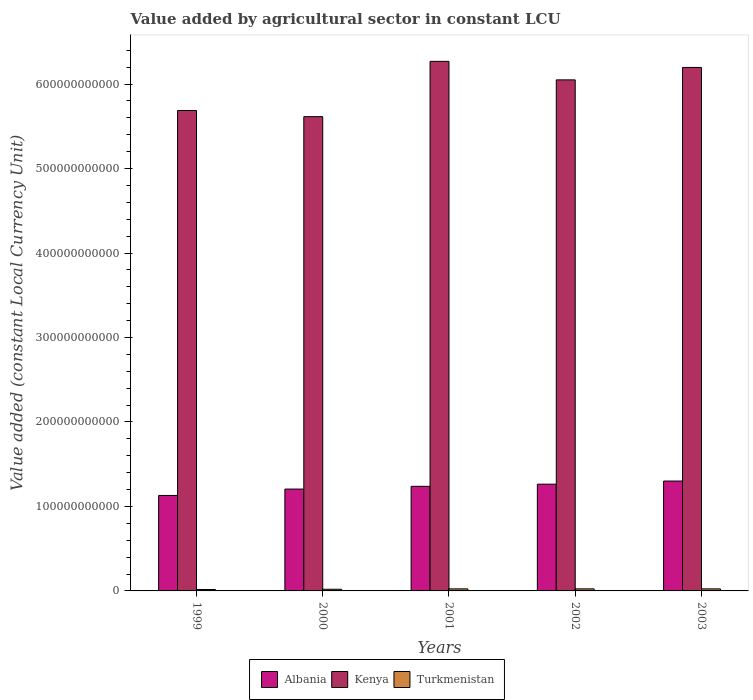How many different coloured bars are there?
Make the answer very short. 3. Are the number of bars per tick equal to the number of legend labels?
Provide a short and direct response. Yes. What is the label of the 1st group of bars from the left?
Provide a succinct answer. 1999. In how many cases, is the number of bars for a given year not equal to the number of legend labels?
Provide a succinct answer. 0. What is the value added by agricultural sector in Turkmenistan in 2001?
Give a very brief answer. 2.43e+09. Across all years, what is the maximum value added by agricultural sector in Turkmenistan?
Provide a short and direct response. 2.43e+09. Across all years, what is the minimum value added by agricultural sector in Albania?
Your response must be concise. 1.13e+11. In which year was the value added by agricultural sector in Albania minimum?
Give a very brief answer. 1999. What is the total value added by agricultural sector in Albania in the graph?
Your answer should be compact. 6.14e+11. What is the difference between the value added by agricultural sector in Turkmenistan in 2001 and that in 2002?
Provide a succinct answer. -2.31e+06. What is the difference between the value added by agricultural sector in Turkmenistan in 2003 and the value added by agricultural sector in Kenya in 2002?
Provide a succinct answer. -6.03e+11. What is the average value added by agricultural sector in Albania per year?
Your response must be concise. 1.23e+11. In the year 2001, what is the difference between the value added by agricultural sector in Turkmenistan and value added by agricultural sector in Albania?
Make the answer very short. -1.21e+11. What is the ratio of the value added by agricultural sector in Turkmenistan in 2000 to that in 2001?
Your answer should be very brief. 0.81. What is the difference between the highest and the second highest value added by agricultural sector in Turkmenistan?
Your response must be concise. 2.41e+06. What is the difference between the highest and the lowest value added by agricultural sector in Kenya?
Your response must be concise. 6.55e+1. What does the 1st bar from the left in 2003 represents?
Give a very brief answer. Albania. What does the 3rd bar from the right in 2001 represents?
Provide a succinct answer. Albania. How many bars are there?
Your answer should be compact. 15. What is the difference between two consecutive major ticks on the Y-axis?
Offer a terse response. 1.00e+11. Where does the legend appear in the graph?
Keep it short and to the point. Bottom center. How are the legend labels stacked?
Your response must be concise. Horizontal. What is the title of the graph?
Your response must be concise. Value added by agricultural sector in constant LCU. Does "Fiji" appear as one of the legend labels in the graph?
Offer a terse response. No. What is the label or title of the Y-axis?
Make the answer very short. Value added (constant Local Currency Unit). What is the Value added (constant Local Currency Unit) of Albania in 1999?
Your answer should be very brief. 1.13e+11. What is the Value added (constant Local Currency Unit) in Kenya in 1999?
Give a very brief answer. 5.69e+11. What is the Value added (constant Local Currency Unit) of Turkmenistan in 1999?
Your response must be concise. 1.69e+09. What is the Value added (constant Local Currency Unit) of Albania in 2000?
Your answer should be very brief. 1.21e+11. What is the Value added (constant Local Currency Unit) in Kenya in 2000?
Provide a succinct answer. 5.61e+11. What is the Value added (constant Local Currency Unit) of Turkmenistan in 2000?
Keep it short and to the point. 1.98e+09. What is the Value added (constant Local Currency Unit) in Albania in 2001?
Your answer should be very brief. 1.24e+11. What is the Value added (constant Local Currency Unit) of Kenya in 2001?
Give a very brief answer. 6.27e+11. What is the Value added (constant Local Currency Unit) in Turkmenistan in 2001?
Make the answer very short. 2.43e+09. What is the Value added (constant Local Currency Unit) in Albania in 2002?
Ensure brevity in your answer.  1.26e+11. What is the Value added (constant Local Currency Unit) in Kenya in 2002?
Give a very brief answer. 6.05e+11. What is the Value added (constant Local Currency Unit) of Turkmenistan in 2002?
Provide a succinct answer. 2.43e+09. What is the Value added (constant Local Currency Unit) in Albania in 2003?
Your answer should be compact. 1.30e+11. What is the Value added (constant Local Currency Unit) of Kenya in 2003?
Your response must be concise. 6.20e+11. What is the Value added (constant Local Currency Unit) in Turkmenistan in 2003?
Your answer should be compact. 2.43e+09. Across all years, what is the maximum Value added (constant Local Currency Unit) of Albania?
Your answer should be compact. 1.30e+11. Across all years, what is the maximum Value added (constant Local Currency Unit) of Kenya?
Offer a terse response. 6.27e+11. Across all years, what is the maximum Value added (constant Local Currency Unit) of Turkmenistan?
Your answer should be very brief. 2.43e+09. Across all years, what is the minimum Value added (constant Local Currency Unit) of Albania?
Provide a short and direct response. 1.13e+11. Across all years, what is the minimum Value added (constant Local Currency Unit) in Kenya?
Provide a succinct answer. 5.61e+11. Across all years, what is the minimum Value added (constant Local Currency Unit) in Turkmenistan?
Provide a short and direct response. 1.69e+09. What is the total Value added (constant Local Currency Unit) of Albania in the graph?
Your answer should be very brief. 6.14e+11. What is the total Value added (constant Local Currency Unit) of Kenya in the graph?
Offer a very short reply. 2.98e+12. What is the total Value added (constant Local Currency Unit) of Turkmenistan in the graph?
Offer a very short reply. 1.10e+1. What is the difference between the Value added (constant Local Currency Unit) of Albania in 1999 and that in 2000?
Offer a very short reply. -7.56e+09. What is the difference between the Value added (constant Local Currency Unit) in Kenya in 1999 and that in 2000?
Make the answer very short. 7.26e+09. What is the difference between the Value added (constant Local Currency Unit) of Turkmenistan in 1999 and that in 2000?
Offer a very short reply. -2.87e+08. What is the difference between the Value added (constant Local Currency Unit) of Albania in 1999 and that in 2001?
Offer a terse response. -1.08e+1. What is the difference between the Value added (constant Local Currency Unit) in Kenya in 1999 and that in 2001?
Ensure brevity in your answer.  -5.82e+1. What is the difference between the Value added (constant Local Currency Unit) of Turkmenistan in 1999 and that in 2001?
Your answer should be compact. -7.41e+08. What is the difference between the Value added (constant Local Currency Unit) in Albania in 1999 and that in 2002?
Keep it short and to the point. -1.33e+1. What is the difference between the Value added (constant Local Currency Unit) in Kenya in 1999 and that in 2002?
Your response must be concise. -3.63e+1. What is the difference between the Value added (constant Local Currency Unit) in Turkmenistan in 1999 and that in 2002?
Provide a short and direct response. -7.44e+08. What is the difference between the Value added (constant Local Currency Unit) in Albania in 1999 and that in 2003?
Keep it short and to the point. -1.71e+1. What is the difference between the Value added (constant Local Currency Unit) in Kenya in 1999 and that in 2003?
Provide a succinct answer. -5.10e+1. What is the difference between the Value added (constant Local Currency Unit) in Turkmenistan in 1999 and that in 2003?
Give a very brief answer. -7.46e+08. What is the difference between the Value added (constant Local Currency Unit) of Albania in 2000 and that in 2001?
Keep it short and to the point. -3.25e+09. What is the difference between the Value added (constant Local Currency Unit) in Kenya in 2000 and that in 2001?
Offer a terse response. -6.55e+1. What is the difference between the Value added (constant Local Currency Unit) in Turkmenistan in 2000 and that in 2001?
Offer a terse response. -4.54e+08. What is the difference between the Value added (constant Local Currency Unit) of Albania in 2000 and that in 2002?
Ensure brevity in your answer.  -5.79e+09. What is the difference between the Value added (constant Local Currency Unit) in Kenya in 2000 and that in 2002?
Your answer should be very brief. -4.35e+1. What is the difference between the Value added (constant Local Currency Unit) of Turkmenistan in 2000 and that in 2002?
Provide a succinct answer. -4.57e+08. What is the difference between the Value added (constant Local Currency Unit) in Albania in 2000 and that in 2003?
Your answer should be compact. -9.51e+09. What is the difference between the Value added (constant Local Currency Unit) in Kenya in 2000 and that in 2003?
Provide a short and direct response. -5.82e+1. What is the difference between the Value added (constant Local Currency Unit) of Turkmenistan in 2000 and that in 2003?
Offer a very short reply. -4.59e+08. What is the difference between the Value added (constant Local Currency Unit) of Albania in 2001 and that in 2002?
Your answer should be compact. -2.54e+09. What is the difference between the Value added (constant Local Currency Unit) in Kenya in 2001 and that in 2002?
Provide a succinct answer. 2.19e+1. What is the difference between the Value added (constant Local Currency Unit) of Turkmenistan in 2001 and that in 2002?
Provide a short and direct response. -2.31e+06. What is the difference between the Value added (constant Local Currency Unit) in Albania in 2001 and that in 2003?
Ensure brevity in your answer.  -6.26e+09. What is the difference between the Value added (constant Local Currency Unit) in Kenya in 2001 and that in 2003?
Ensure brevity in your answer.  7.21e+09. What is the difference between the Value added (constant Local Currency Unit) in Turkmenistan in 2001 and that in 2003?
Your response must be concise. -4.72e+06. What is the difference between the Value added (constant Local Currency Unit) of Albania in 2002 and that in 2003?
Ensure brevity in your answer.  -3.72e+09. What is the difference between the Value added (constant Local Currency Unit) of Kenya in 2002 and that in 2003?
Offer a very short reply. -1.47e+1. What is the difference between the Value added (constant Local Currency Unit) in Turkmenistan in 2002 and that in 2003?
Offer a terse response. -2.41e+06. What is the difference between the Value added (constant Local Currency Unit) in Albania in 1999 and the Value added (constant Local Currency Unit) in Kenya in 2000?
Provide a short and direct response. -4.48e+11. What is the difference between the Value added (constant Local Currency Unit) of Albania in 1999 and the Value added (constant Local Currency Unit) of Turkmenistan in 2000?
Your answer should be very brief. 1.11e+11. What is the difference between the Value added (constant Local Currency Unit) in Kenya in 1999 and the Value added (constant Local Currency Unit) in Turkmenistan in 2000?
Ensure brevity in your answer.  5.67e+11. What is the difference between the Value added (constant Local Currency Unit) of Albania in 1999 and the Value added (constant Local Currency Unit) of Kenya in 2001?
Your answer should be very brief. -5.14e+11. What is the difference between the Value added (constant Local Currency Unit) in Albania in 1999 and the Value added (constant Local Currency Unit) in Turkmenistan in 2001?
Your answer should be very brief. 1.11e+11. What is the difference between the Value added (constant Local Currency Unit) of Kenya in 1999 and the Value added (constant Local Currency Unit) of Turkmenistan in 2001?
Offer a very short reply. 5.66e+11. What is the difference between the Value added (constant Local Currency Unit) in Albania in 1999 and the Value added (constant Local Currency Unit) in Kenya in 2002?
Ensure brevity in your answer.  -4.92e+11. What is the difference between the Value added (constant Local Currency Unit) in Albania in 1999 and the Value added (constant Local Currency Unit) in Turkmenistan in 2002?
Your answer should be very brief. 1.11e+11. What is the difference between the Value added (constant Local Currency Unit) in Kenya in 1999 and the Value added (constant Local Currency Unit) in Turkmenistan in 2002?
Make the answer very short. 5.66e+11. What is the difference between the Value added (constant Local Currency Unit) in Albania in 1999 and the Value added (constant Local Currency Unit) in Kenya in 2003?
Make the answer very short. -5.07e+11. What is the difference between the Value added (constant Local Currency Unit) of Albania in 1999 and the Value added (constant Local Currency Unit) of Turkmenistan in 2003?
Offer a very short reply. 1.11e+11. What is the difference between the Value added (constant Local Currency Unit) of Kenya in 1999 and the Value added (constant Local Currency Unit) of Turkmenistan in 2003?
Give a very brief answer. 5.66e+11. What is the difference between the Value added (constant Local Currency Unit) in Albania in 2000 and the Value added (constant Local Currency Unit) in Kenya in 2001?
Provide a succinct answer. -5.06e+11. What is the difference between the Value added (constant Local Currency Unit) in Albania in 2000 and the Value added (constant Local Currency Unit) in Turkmenistan in 2001?
Keep it short and to the point. 1.18e+11. What is the difference between the Value added (constant Local Currency Unit) of Kenya in 2000 and the Value added (constant Local Currency Unit) of Turkmenistan in 2001?
Keep it short and to the point. 5.59e+11. What is the difference between the Value added (constant Local Currency Unit) of Albania in 2000 and the Value added (constant Local Currency Unit) of Kenya in 2002?
Offer a very short reply. -4.84e+11. What is the difference between the Value added (constant Local Currency Unit) in Albania in 2000 and the Value added (constant Local Currency Unit) in Turkmenistan in 2002?
Your response must be concise. 1.18e+11. What is the difference between the Value added (constant Local Currency Unit) in Kenya in 2000 and the Value added (constant Local Currency Unit) in Turkmenistan in 2002?
Your answer should be compact. 5.59e+11. What is the difference between the Value added (constant Local Currency Unit) in Albania in 2000 and the Value added (constant Local Currency Unit) in Kenya in 2003?
Provide a succinct answer. -4.99e+11. What is the difference between the Value added (constant Local Currency Unit) of Albania in 2000 and the Value added (constant Local Currency Unit) of Turkmenistan in 2003?
Offer a terse response. 1.18e+11. What is the difference between the Value added (constant Local Currency Unit) in Kenya in 2000 and the Value added (constant Local Currency Unit) in Turkmenistan in 2003?
Ensure brevity in your answer.  5.59e+11. What is the difference between the Value added (constant Local Currency Unit) of Albania in 2001 and the Value added (constant Local Currency Unit) of Kenya in 2002?
Offer a very short reply. -4.81e+11. What is the difference between the Value added (constant Local Currency Unit) in Albania in 2001 and the Value added (constant Local Currency Unit) in Turkmenistan in 2002?
Offer a very short reply. 1.21e+11. What is the difference between the Value added (constant Local Currency Unit) in Kenya in 2001 and the Value added (constant Local Currency Unit) in Turkmenistan in 2002?
Give a very brief answer. 6.24e+11. What is the difference between the Value added (constant Local Currency Unit) in Albania in 2001 and the Value added (constant Local Currency Unit) in Kenya in 2003?
Your answer should be compact. -4.96e+11. What is the difference between the Value added (constant Local Currency Unit) of Albania in 2001 and the Value added (constant Local Currency Unit) of Turkmenistan in 2003?
Provide a short and direct response. 1.21e+11. What is the difference between the Value added (constant Local Currency Unit) in Kenya in 2001 and the Value added (constant Local Currency Unit) in Turkmenistan in 2003?
Ensure brevity in your answer.  6.24e+11. What is the difference between the Value added (constant Local Currency Unit) of Albania in 2002 and the Value added (constant Local Currency Unit) of Kenya in 2003?
Your answer should be very brief. -4.93e+11. What is the difference between the Value added (constant Local Currency Unit) of Albania in 2002 and the Value added (constant Local Currency Unit) of Turkmenistan in 2003?
Your answer should be compact. 1.24e+11. What is the difference between the Value added (constant Local Currency Unit) of Kenya in 2002 and the Value added (constant Local Currency Unit) of Turkmenistan in 2003?
Give a very brief answer. 6.03e+11. What is the average Value added (constant Local Currency Unit) in Albania per year?
Give a very brief answer. 1.23e+11. What is the average Value added (constant Local Currency Unit) of Kenya per year?
Your answer should be very brief. 5.96e+11. What is the average Value added (constant Local Currency Unit) of Turkmenistan per year?
Your response must be concise. 2.19e+09. In the year 1999, what is the difference between the Value added (constant Local Currency Unit) of Albania and Value added (constant Local Currency Unit) of Kenya?
Your response must be concise. -4.56e+11. In the year 1999, what is the difference between the Value added (constant Local Currency Unit) of Albania and Value added (constant Local Currency Unit) of Turkmenistan?
Your answer should be compact. 1.11e+11. In the year 1999, what is the difference between the Value added (constant Local Currency Unit) in Kenya and Value added (constant Local Currency Unit) in Turkmenistan?
Ensure brevity in your answer.  5.67e+11. In the year 2000, what is the difference between the Value added (constant Local Currency Unit) in Albania and Value added (constant Local Currency Unit) in Kenya?
Provide a short and direct response. -4.41e+11. In the year 2000, what is the difference between the Value added (constant Local Currency Unit) of Albania and Value added (constant Local Currency Unit) of Turkmenistan?
Your answer should be compact. 1.19e+11. In the year 2000, what is the difference between the Value added (constant Local Currency Unit) of Kenya and Value added (constant Local Currency Unit) of Turkmenistan?
Offer a terse response. 5.59e+11. In the year 2001, what is the difference between the Value added (constant Local Currency Unit) of Albania and Value added (constant Local Currency Unit) of Kenya?
Make the answer very short. -5.03e+11. In the year 2001, what is the difference between the Value added (constant Local Currency Unit) of Albania and Value added (constant Local Currency Unit) of Turkmenistan?
Your answer should be very brief. 1.21e+11. In the year 2001, what is the difference between the Value added (constant Local Currency Unit) in Kenya and Value added (constant Local Currency Unit) in Turkmenistan?
Your response must be concise. 6.24e+11. In the year 2002, what is the difference between the Value added (constant Local Currency Unit) of Albania and Value added (constant Local Currency Unit) of Kenya?
Your answer should be very brief. -4.79e+11. In the year 2002, what is the difference between the Value added (constant Local Currency Unit) of Albania and Value added (constant Local Currency Unit) of Turkmenistan?
Give a very brief answer. 1.24e+11. In the year 2002, what is the difference between the Value added (constant Local Currency Unit) of Kenya and Value added (constant Local Currency Unit) of Turkmenistan?
Ensure brevity in your answer.  6.03e+11. In the year 2003, what is the difference between the Value added (constant Local Currency Unit) in Albania and Value added (constant Local Currency Unit) in Kenya?
Make the answer very short. -4.90e+11. In the year 2003, what is the difference between the Value added (constant Local Currency Unit) of Albania and Value added (constant Local Currency Unit) of Turkmenistan?
Provide a succinct answer. 1.28e+11. In the year 2003, what is the difference between the Value added (constant Local Currency Unit) of Kenya and Value added (constant Local Currency Unit) of Turkmenistan?
Provide a short and direct response. 6.17e+11. What is the ratio of the Value added (constant Local Currency Unit) in Albania in 1999 to that in 2000?
Offer a very short reply. 0.94. What is the ratio of the Value added (constant Local Currency Unit) of Kenya in 1999 to that in 2000?
Provide a short and direct response. 1.01. What is the ratio of the Value added (constant Local Currency Unit) of Turkmenistan in 1999 to that in 2000?
Keep it short and to the point. 0.85. What is the ratio of the Value added (constant Local Currency Unit) of Albania in 1999 to that in 2001?
Keep it short and to the point. 0.91. What is the ratio of the Value added (constant Local Currency Unit) of Kenya in 1999 to that in 2001?
Keep it short and to the point. 0.91. What is the ratio of the Value added (constant Local Currency Unit) of Turkmenistan in 1999 to that in 2001?
Provide a succinct answer. 0.69. What is the ratio of the Value added (constant Local Currency Unit) in Albania in 1999 to that in 2002?
Offer a terse response. 0.89. What is the ratio of the Value added (constant Local Currency Unit) of Turkmenistan in 1999 to that in 2002?
Give a very brief answer. 0.69. What is the ratio of the Value added (constant Local Currency Unit) in Albania in 1999 to that in 2003?
Provide a succinct answer. 0.87. What is the ratio of the Value added (constant Local Currency Unit) in Kenya in 1999 to that in 2003?
Keep it short and to the point. 0.92. What is the ratio of the Value added (constant Local Currency Unit) in Turkmenistan in 1999 to that in 2003?
Make the answer very short. 0.69. What is the ratio of the Value added (constant Local Currency Unit) of Albania in 2000 to that in 2001?
Ensure brevity in your answer.  0.97. What is the ratio of the Value added (constant Local Currency Unit) of Kenya in 2000 to that in 2001?
Make the answer very short. 0.9. What is the ratio of the Value added (constant Local Currency Unit) in Turkmenistan in 2000 to that in 2001?
Your answer should be very brief. 0.81. What is the ratio of the Value added (constant Local Currency Unit) in Albania in 2000 to that in 2002?
Offer a very short reply. 0.95. What is the ratio of the Value added (constant Local Currency Unit) in Kenya in 2000 to that in 2002?
Keep it short and to the point. 0.93. What is the ratio of the Value added (constant Local Currency Unit) in Turkmenistan in 2000 to that in 2002?
Your answer should be very brief. 0.81. What is the ratio of the Value added (constant Local Currency Unit) of Albania in 2000 to that in 2003?
Offer a very short reply. 0.93. What is the ratio of the Value added (constant Local Currency Unit) of Kenya in 2000 to that in 2003?
Offer a very short reply. 0.91. What is the ratio of the Value added (constant Local Currency Unit) of Turkmenistan in 2000 to that in 2003?
Offer a terse response. 0.81. What is the ratio of the Value added (constant Local Currency Unit) of Albania in 2001 to that in 2002?
Make the answer very short. 0.98. What is the ratio of the Value added (constant Local Currency Unit) of Kenya in 2001 to that in 2002?
Ensure brevity in your answer.  1.04. What is the ratio of the Value added (constant Local Currency Unit) of Turkmenistan in 2001 to that in 2002?
Offer a terse response. 1. What is the ratio of the Value added (constant Local Currency Unit) of Albania in 2001 to that in 2003?
Provide a short and direct response. 0.95. What is the ratio of the Value added (constant Local Currency Unit) of Kenya in 2001 to that in 2003?
Provide a succinct answer. 1.01. What is the ratio of the Value added (constant Local Currency Unit) in Albania in 2002 to that in 2003?
Offer a very short reply. 0.97. What is the ratio of the Value added (constant Local Currency Unit) of Kenya in 2002 to that in 2003?
Make the answer very short. 0.98. What is the difference between the highest and the second highest Value added (constant Local Currency Unit) in Albania?
Give a very brief answer. 3.72e+09. What is the difference between the highest and the second highest Value added (constant Local Currency Unit) of Kenya?
Your answer should be very brief. 7.21e+09. What is the difference between the highest and the second highest Value added (constant Local Currency Unit) in Turkmenistan?
Give a very brief answer. 2.41e+06. What is the difference between the highest and the lowest Value added (constant Local Currency Unit) of Albania?
Ensure brevity in your answer.  1.71e+1. What is the difference between the highest and the lowest Value added (constant Local Currency Unit) of Kenya?
Your answer should be compact. 6.55e+1. What is the difference between the highest and the lowest Value added (constant Local Currency Unit) of Turkmenistan?
Make the answer very short. 7.46e+08. 